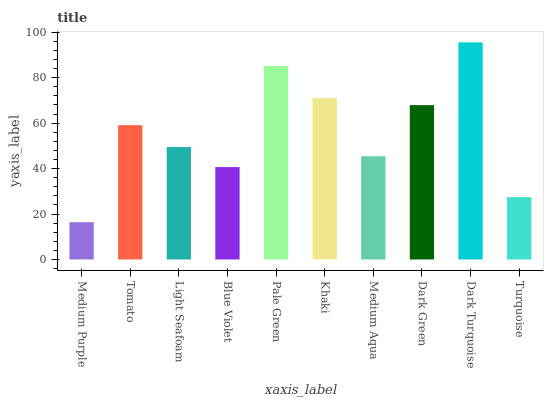Is Medium Purple the minimum?
Answer yes or no. Yes. Is Dark Turquoise the maximum?
Answer yes or no. Yes. Is Tomato the minimum?
Answer yes or no. No. Is Tomato the maximum?
Answer yes or no. No. Is Tomato greater than Medium Purple?
Answer yes or no. Yes. Is Medium Purple less than Tomato?
Answer yes or no. Yes. Is Medium Purple greater than Tomato?
Answer yes or no. No. Is Tomato less than Medium Purple?
Answer yes or no. No. Is Tomato the high median?
Answer yes or no. Yes. Is Light Seafoam the low median?
Answer yes or no. Yes. Is Medium Aqua the high median?
Answer yes or no. No. Is Dark Turquoise the low median?
Answer yes or no. No. 